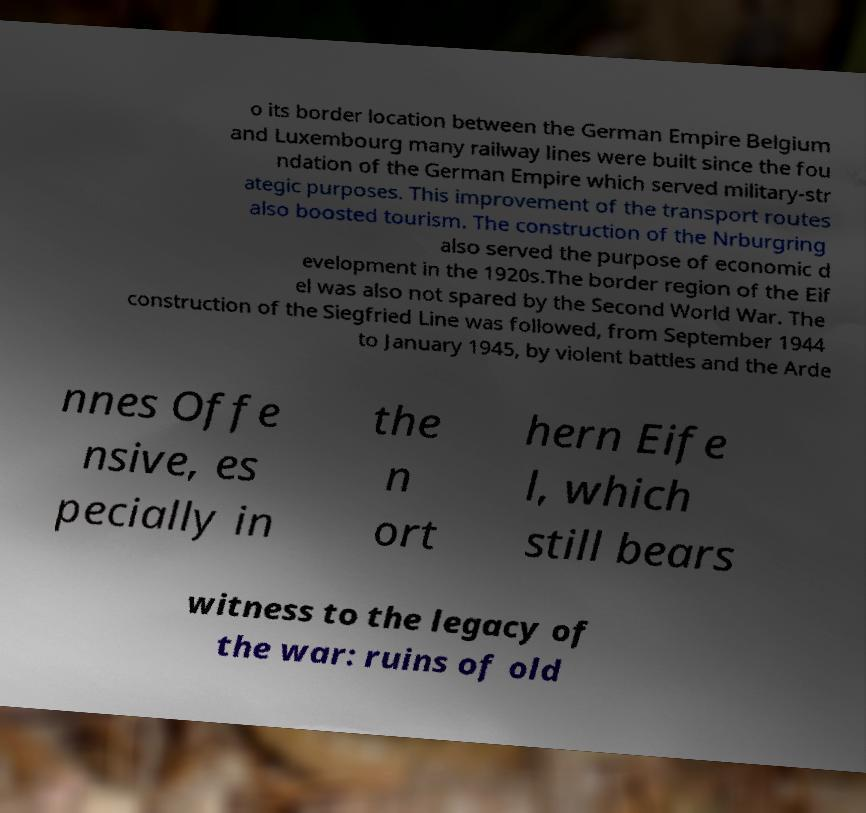I need the written content from this picture converted into text. Can you do that? o its border location between the German Empire Belgium and Luxembourg many railway lines were built since the fou ndation of the German Empire which served military-str ategic purposes. This improvement of the transport routes also boosted tourism. The construction of the Nrburgring also served the purpose of economic d evelopment in the 1920s.The border region of the Eif el was also not spared by the Second World War. The construction of the Siegfried Line was followed, from September 1944 to January 1945, by violent battles and the Arde nnes Offe nsive, es pecially in the n ort hern Eife l, which still bears witness to the legacy of the war: ruins of old 